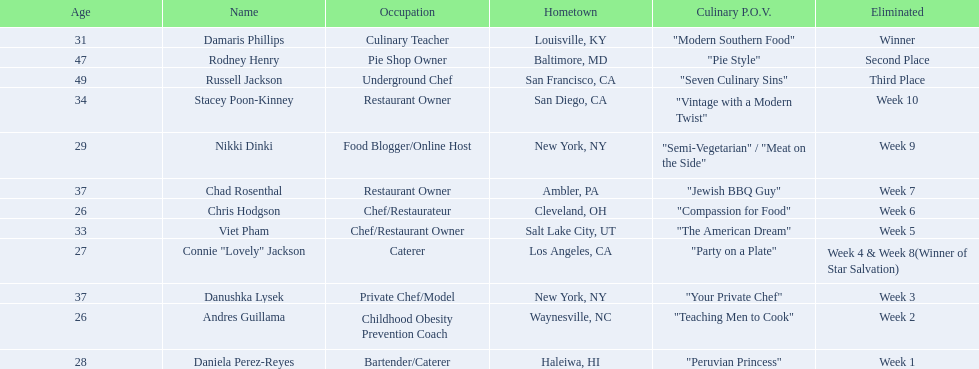Who where the people in the food network? Damaris Phillips, Rodney Henry, Russell Jackson, Stacey Poon-Kinney, Nikki Dinki, Chad Rosenthal, Chris Hodgson, Viet Pham, Connie "Lovely" Jackson, Danushka Lysek, Andres Guillama, Daniela Perez-Reyes. When was nikki dinki eliminated? Week 9. When was viet pham eliminated? Week 5. Which of these two is earlier? Week 5. Who was eliminated in this week? Viet Pham. 